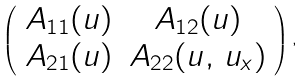Convert formula to latex. <formula><loc_0><loc_0><loc_500><loc_500>\left ( \begin{array} { c c } A _ { 1 1 } ( u ) & A _ { 1 2 } ( u ) \\ A _ { 2 1 } ( u ) & A _ { 2 2 } ( u , \, u _ { x } ) \\ \end{array} \right ) ,</formula> 